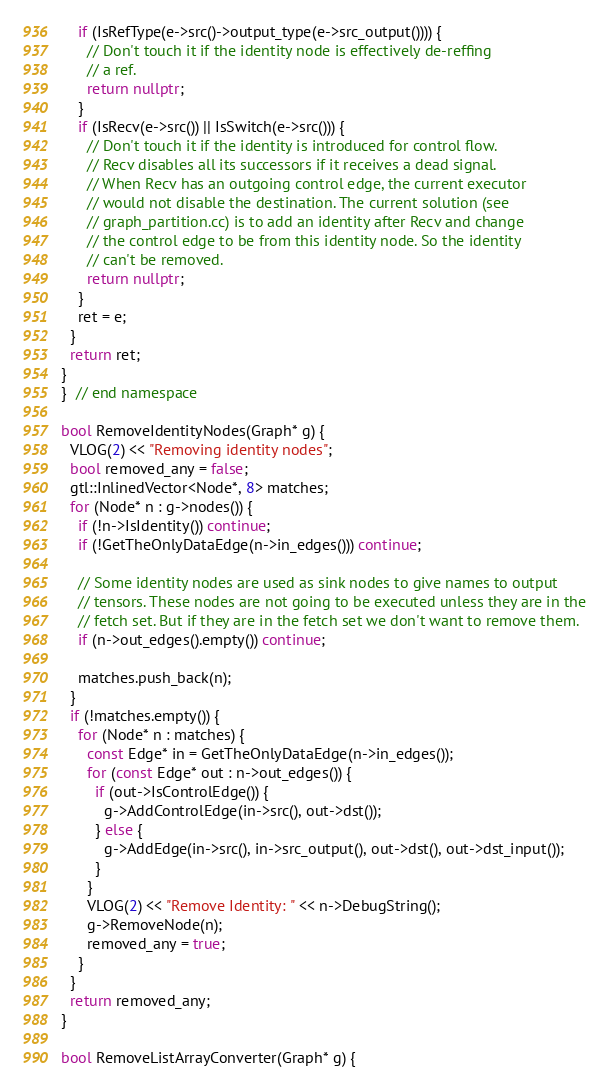<code> <loc_0><loc_0><loc_500><loc_500><_C++_>    if (IsRefType(e->src()->output_type(e->src_output()))) {
      // Don't touch it if the identity node is effectively de-reffing
      // a ref.
      return nullptr;
    }
    if (IsRecv(e->src()) || IsSwitch(e->src())) {
      // Don't touch it if the identity is introduced for control flow.
      // Recv disables all its successors if it receives a dead signal.
      // When Recv has an outgoing control edge, the current executor
      // would not disable the destination. The current solution (see
      // graph_partition.cc) is to add an identity after Recv and change
      // the control edge to be from this identity node. So the identity
      // can't be removed.
      return nullptr;
    }
    ret = e;
  }
  return ret;
}
}  // end namespace

bool RemoveIdentityNodes(Graph* g) {
  VLOG(2) << "Removing identity nodes";
  bool removed_any = false;
  gtl::InlinedVector<Node*, 8> matches;
  for (Node* n : g->nodes()) {
    if (!n->IsIdentity()) continue;
    if (!GetTheOnlyDataEdge(n->in_edges())) continue;

    // Some identity nodes are used as sink nodes to give names to output
    // tensors. These nodes are not going to be executed unless they are in the
    // fetch set. But if they are in the fetch set we don't want to remove them.
    if (n->out_edges().empty()) continue;

    matches.push_back(n);
  }
  if (!matches.empty()) {
    for (Node* n : matches) {
      const Edge* in = GetTheOnlyDataEdge(n->in_edges());
      for (const Edge* out : n->out_edges()) {
        if (out->IsControlEdge()) {
          g->AddControlEdge(in->src(), out->dst());
        } else {
          g->AddEdge(in->src(), in->src_output(), out->dst(), out->dst_input());
        }
      }
      VLOG(2) << "Remove Identity: " << n->DebugString();
      g->RemoveNode(n);
      removed_any = true;
    }
  }
  return removed_any;
}

bool RemoveListArrayConverter(Graph* g) {</code> 